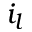Convert formula to latex. <formula><loc_0><loc_0><loc_500><loc_500>i _ { l }</formula> 